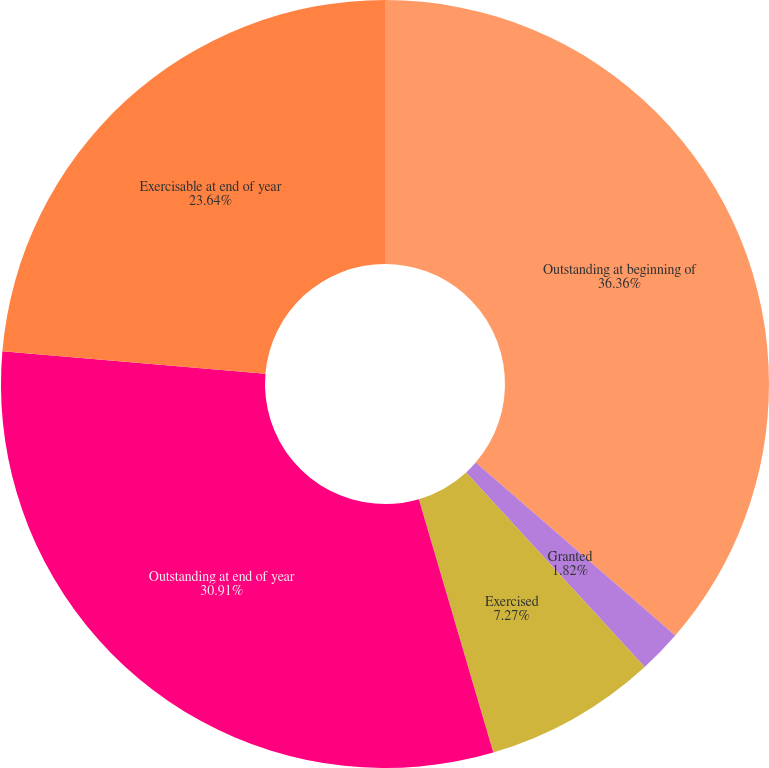Convert chart. <chart><loc_0><loc_0><loc_500><loc_500><pie_chart><fcel>Outstanding at beginning of<fcel>Granted<fcel>Exercised<fcel>Outstanding at end of year<fcel>Exercisable at end of year<nl><fcel>36.36%<fcel>1.82%<fcel>7.27%<fcel>30.91%<fcel>23.64%<nl></chart> 